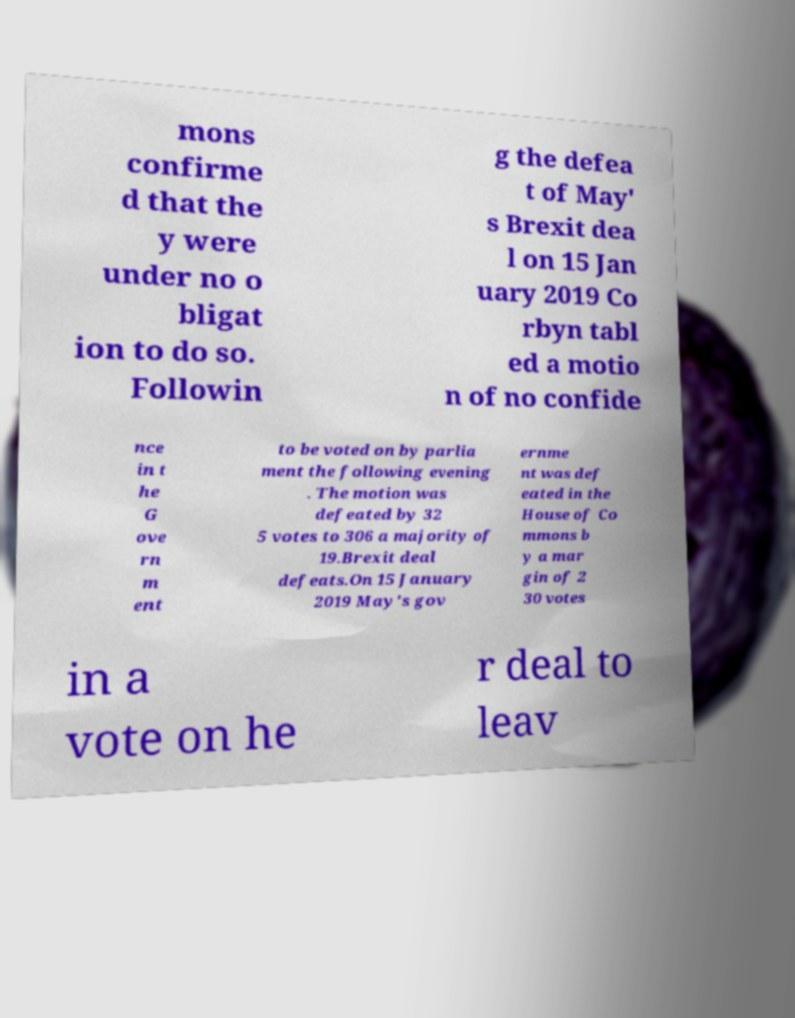Can you read and provide the text displayed in the image?This photo seems to have some interesting text. Can you extract and type it out for me? mons confirme d that the y were under no o bligat ion to do so. Followin g the defea t of May' s Brexit dea l on 15 Jan uary 2019 Co rbyn tabl ed a motio n of no confide nce in t he G ove rn m ent to be voted on by parlia ment the following evening . The motion was defeated by 32 5 votes to 306 a majority of 19.Brexit deal defeats.On 15 January 2019 May's gov ernme nt was def eated in the House of Co mmons b y a mar gin of 2 30 votes in a vote on he r deal to leav 